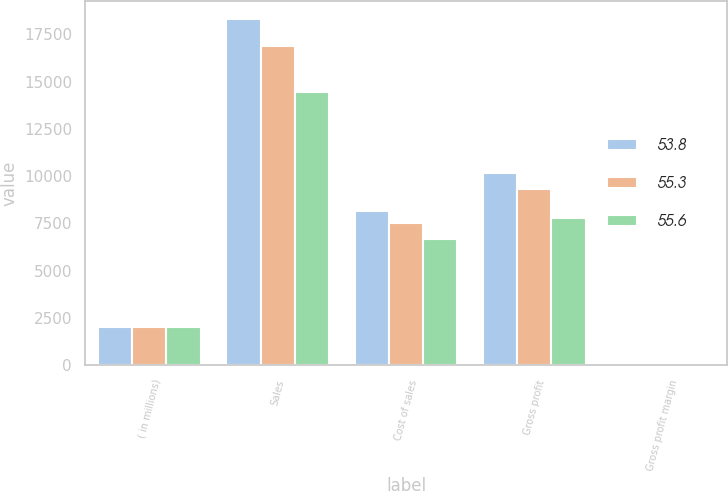Convert chart. <chart><loc_0><loc_0><loc_500><loc_500><stacked_bar_chart><ecel><fcel>( in millions)<fcel>Sales<fcel>Cost of sales<fcel>Gross profit<fcel>Gross profit margin<nl><fcel>53.8<fcel>2017<fcel>18329.7<fcel>8137.2<fcel>10192.5<fcel>55.6<nl><fcel>55.3<fcel>2016<fcel>16882.4<fcel>7547.8<fcel>9334.6<fcel>55.3<nl><fcel>55.6<fcel>2015<fcel>14433.7<fcel>6662.6<fcel>7771.1<fcel>53.8<nl></chart> 